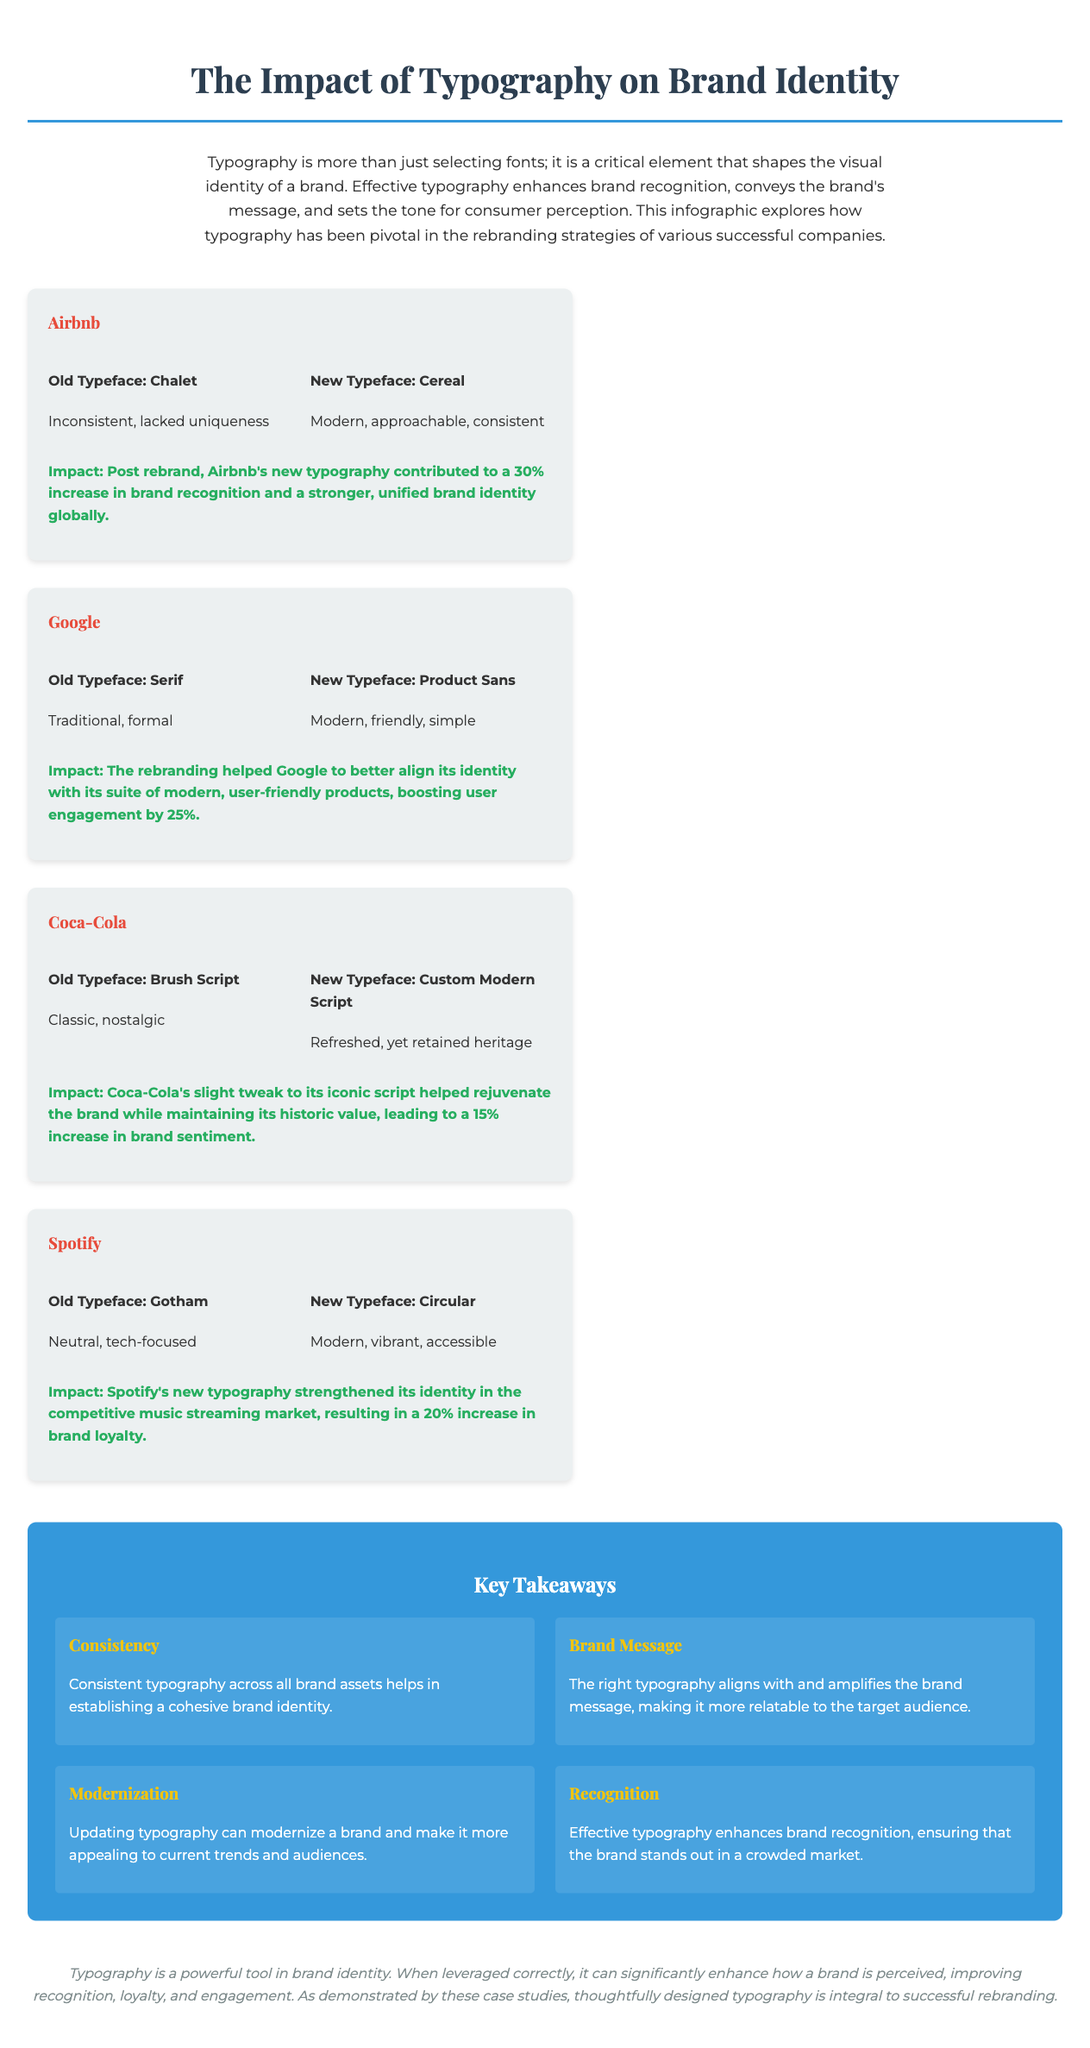What rebrand helped Airbnb's recognition increase by 30%? The document states that Airbnb's new typography contributed to a 30% increase in brand recognition.
Answer: Cereal What was Google’s old typeface? The document lists the old typeface for Google as Serif.
Answer: Serif By what percentage did Google improve user engagement post-rebrand? The revelation shows that Google boosted user engagement by 25% from the rebranding.
Answer: 25% What does Coca-Cola's new typeface reflect? The document indicates that the new typeface for Coca-Cola is "Refreshed, yet retained heritage."
Answer: Refreshed, yet retained heritage Which key takeaway emphasizes the importance of consistent typography? The document includes "Consistency" as a key takeaway regarding typography's role in brand identity.
Answer: Consistency What impact did Spotify's new typography have on brand loyalty? The impact section states that Spotify's typography resulted in a 20% increase in brand loyalty.
Answer: 20% What was the old typeface used by Spotify? The document specifies that Spotify's old typeface was Gotham.
Answer: Gotham Which brand's identity is described as "Modern, approachable, consistent"? The rebranding impact shows this description applies to Airbnb's new typeface.
Answer: Airbnb 